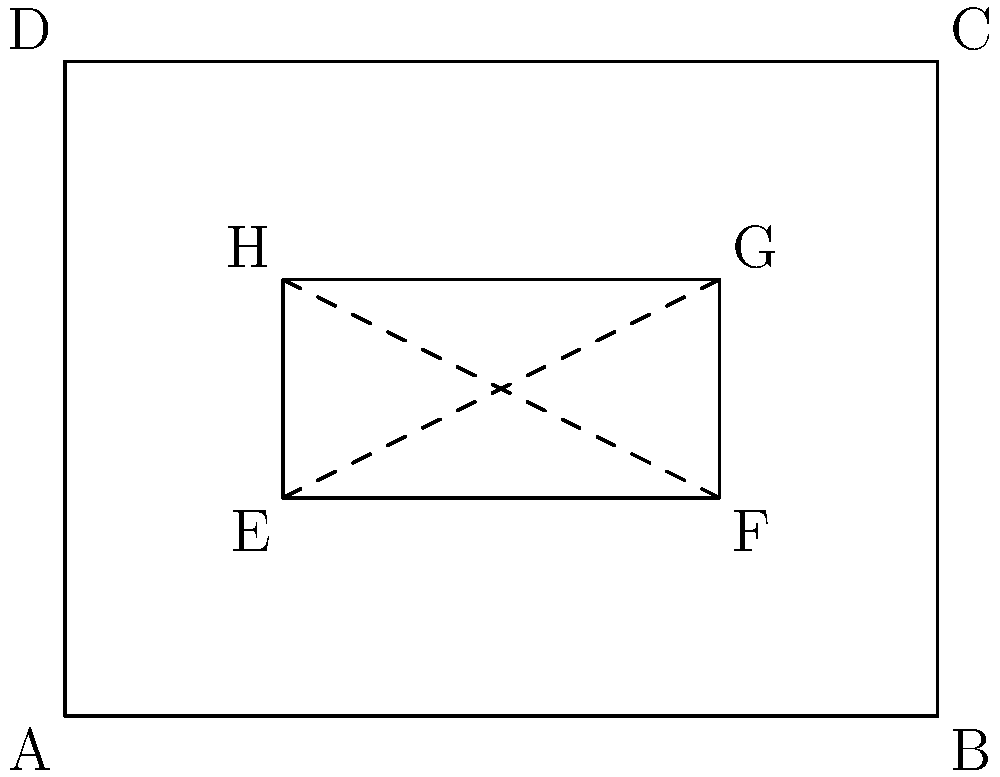In the decorative wooden panel shown above, ABCD represents the outer frame, and EFGH represents an inlaid geometric design. If EG and FH are congruent diagonals, which two triangles formed within EFGH are guaranteed to be congruent? To determine which triangles are congruent, let's follow these steps:

1. We are given that EG and FH are congruent diagonals. This means that $EG \cong FH$.

2. The diagonals EG and FH intersect at a point, creating four triangles within EFGH.

3. When two diagonals of a quadrilateral are congruent and intersect, they bisect each other. This means that the point of intersection is the midpoint of both diagonals.

4. Let's call the point of intersection M. We now know that:
   $EM \cong MG$ and $FM \cong MH$

5. In triangle EFM and triangle HGM:
   - EM ≅ MG (as proved in step 4)
   - FM ≅ MH (as proved in step 4)
   - Angle EMF ≅ Angle GMH (vertical angles are congruent)

6. With two sides and the included angle congruent, we can conclude that triangle EFM is congruent to triangle HGM by the SAS (Side-Angle-Side) congruence criterion.

Therefore, triangle EFM and triangle HGM are guaranteed to be congruent.
Answer: Triangle EFM and triangle HGM 